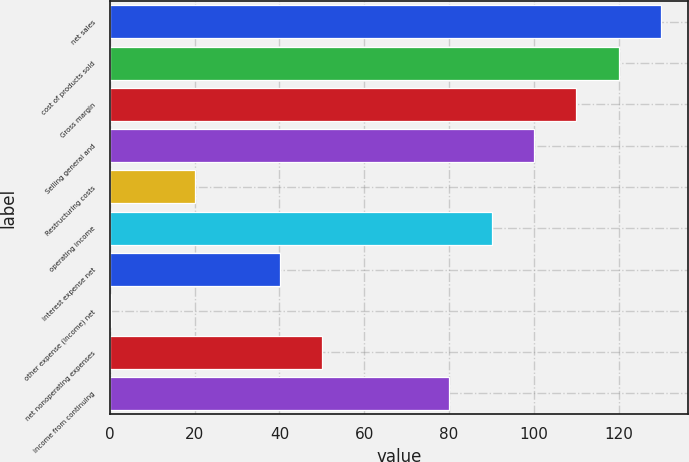Convert chart. <chart><loc_0><loc_0><loc_500><loc_500><bar_chart><fcel>net sales<fcel>cost of products sold<fcel>Gross margin<fcel>Selling general and<fcel>Restructuring costs<fcel>operating income<fcel>interest expense net<fcel>other expense (income) net<fcel>net nonoperating expenses<fcel>income from continuing<nl><fcel>129.94<fcel>119.96<fcel>109.98<fcel>100<fcel>20.16<fcel>90.02<fcel>40.12<fcel>0.2<fcel>50.1<fcel>80.04<nl></chart> 